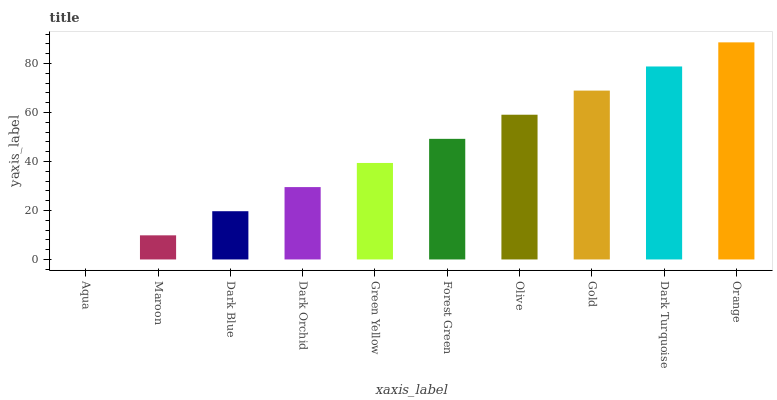Is Maroon the minimum?
Answer yes or no. No. Is Maroon the maximum?
Answer yes or no. No. Is Maroon greater than Aqua?
Answer yes or no. Yes. Is Aqua less than Maroon?
Answer yes or no. Yes. Is Aqua greater than Maroon?
Answer yes or no. No. Is Maroon less than Aqua?
Answer yes or no. No. Is Forest Green the high median?
Answer yes or no. Yes. Is Green Yellow the low median?
Answer yes or no. Yes. Is Orange the high median?
Answer yes or no. No. Is Aqua the low median?
Answer yes or no. No. 